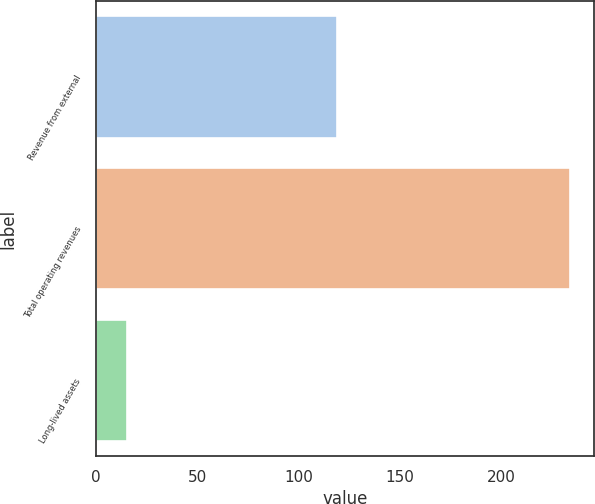Convert chart. <chart><loc_0><loc_0><loc_500><loc_500><bar_chart><fcel>Revenue from external<fcel>Total operating revenues<fcel>Long-lived assets<nl><fcel>118.7<fcel>233.8<fcel>15.3<nl></chart> 